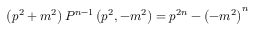Convert formula to latex. <formula><loc_0><loc_0><loc_500><loc_500>\left ( p ^ { 2 } + m ^ { 2 } \right ) P ^ { n - 1 } \left ( p ^ { 2 } , - m ^ { 2 } \right ) = p ^ { 2 n } - { \left ( - m ^ { 2 } \right ) } ^ { n }</formula> 